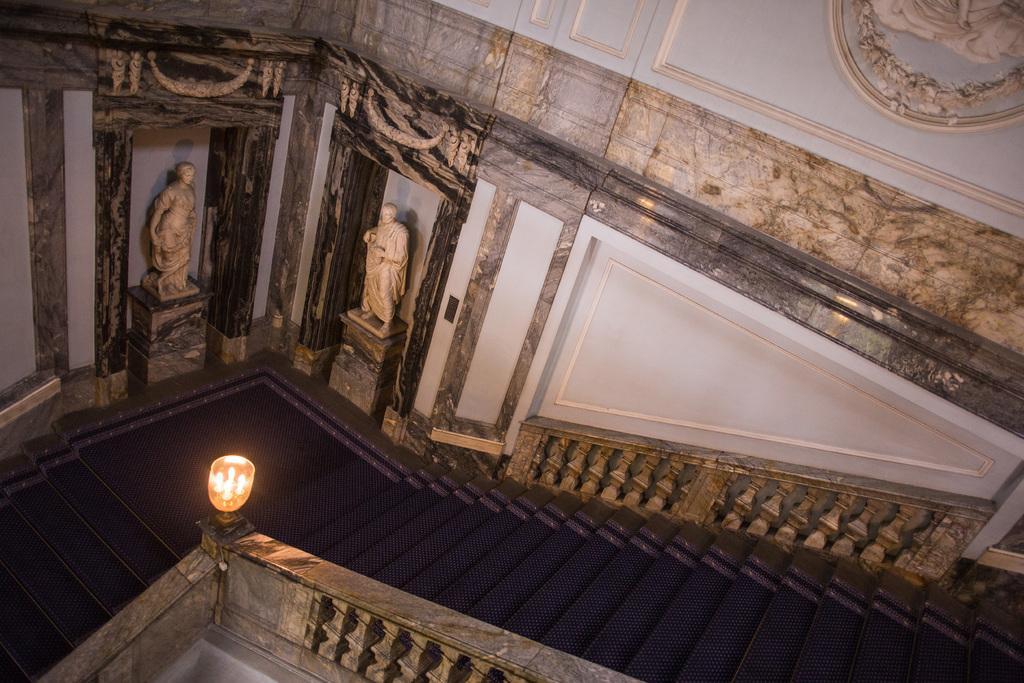Could you give a brief overview of what you see in this image? In the image there are stairs and behind the stairs there are sculptures, in the background there is a wall and there is a light fixed on the railing of the stairs. 